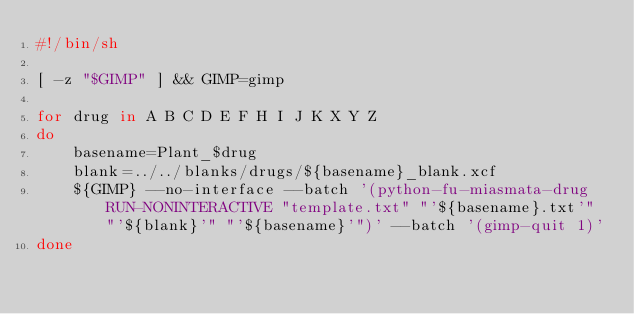<code> <loc_0><loc_0><loc_500><loc_500><_Bash_>#!/bin/sh

[ -z "$GIMP" ] && GIMP=gimp

for drug in A B C D E F H I J K X Y Z
do
	basename=Plant_$drug
	blank=../../blanks/drugs/${basename}_blank.xcf
	${GIMP} --no-interface --batch '(python-fu-miasmata-drug RUN-NONINTERACTIVE "template.txt" "'${basename}.txt'" "'${blank}'" "'${basename}'")' --batch '(gimp-quit 1)'
done
</code> 